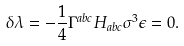<formula> <loc_0><loc_0><loc_500><loc_500>\delta \lambda = - \frac { 1 } { 4 } \Gamma ^ { a b c } H _ { a b c } \sigma ^ { 3 } \epsilon = 0 .</formula> 